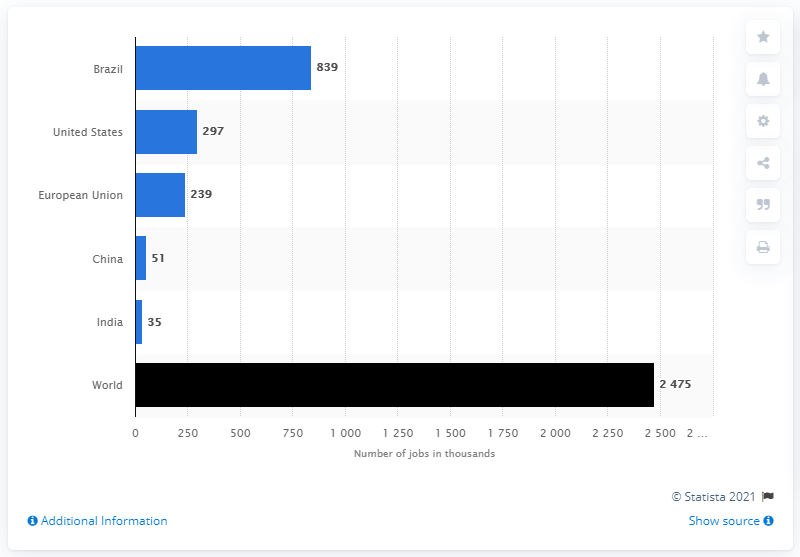Mention a couple of crucial points in this snapshot. Brazil is the leading country in terms of jobs in the biofuels industry. 